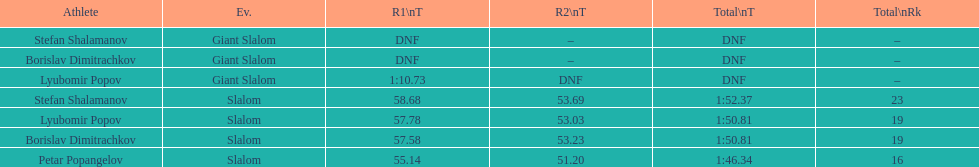What is the number of athletes to finish race one in the giant slalom? 1. 